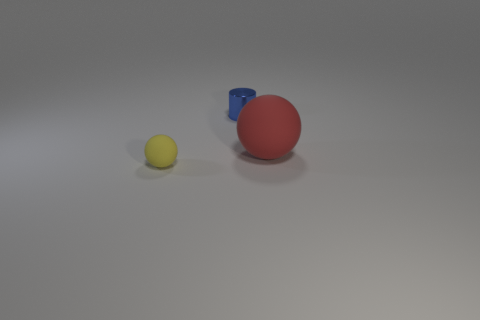Is the number of things that are in front of the red rubber object greater than the number of small purple rubber balls?
Your answer should be compact. Yes. Is the shape of the yellow rubber thing the same as the blue shiny object?
Your answer should be compact. No. The blue shiny cylinder has what size?
Keep it short and to the point. Small. Is the number of small yellow matte things that are behind the small shiny cylinder greater than the number of tiny yellow matte objects that are on the right side of the small yellow sphere?
Keep it short and to the point. No. There is a metallic object; are there any small yellow rubber spheres in front of it?
Ensure brevity in your answer.  Yes. Are there any yellow matte objects that have the same size as the yellow rubber sphere?
Your answer should be compact. No. There is a object that is made of the same material as the large sphere; what is its color?
Your response must be concise. Yellow. What is the material of the small cylinder?
Offer a terse response. Metal. What shape is the red rubber thing?
Provide a short and direct response. Sphere. How many metal cylinders have the same color as the metal object?
Your response must be concise. 0. 